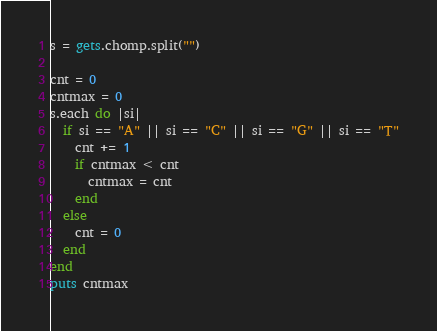<code> <loc_0><loc_0><loc_500><loc_500><_Ruby_>s = gets.chomp.split("")

cnt = 0
cntmax = 0
s.each do |si|
  if si == "A" || si == "C" || si == "G" || si == "T"
    cnt += 1
    if cntmax < cnt
      cntmax = cnt
    end
  else
    cnt = 0
  end
end
puts cntmax</code> 